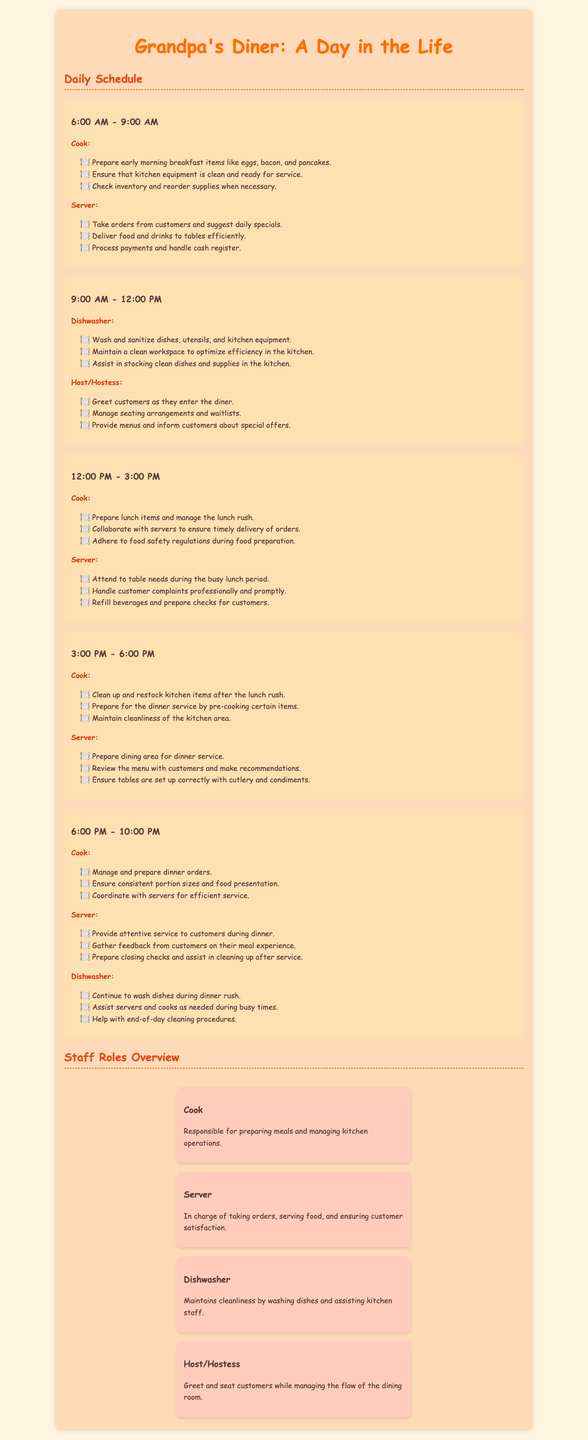what time does the dinner service start? The dinner service starts at 6:00 PM.
Answer: 6:00 PM who is responsible for managing seating arrangements? The host/hostess is responsible for managing seating arrangements.
Answer: Host/Hostess how many roles are listed in the manual? The roles listed include Cook, Server, Dishwasher, and Host/Hostess, totaling four roles.
Answer: 4 what is one task the dishwasher performs during the morning shift? The dishwasher washes and sanitizes dishes, utensils, and kitchen equipment during the morning shift.
Answer: Wash and sanitize dishes what is a duty of the server during the lunch rush? The server attends to table needs during the busy lunch period.
Answer: Attend to table needs how often does the cook check inventory? The cook checks inventory and reorders supplies when necessary, which is typically in the morning shift.
Answer: When necessary what do cooks need to ensure during food preparation? Cooks must adhere to food safety regulations during food preparation.
Answer: Food safety regulations what is the last task mentioned for the dishwasher at night? The last task for the dishwasher at night involves helping with end-of-day cleaning procedures.
Answer: End-of-day cleaning procedures 